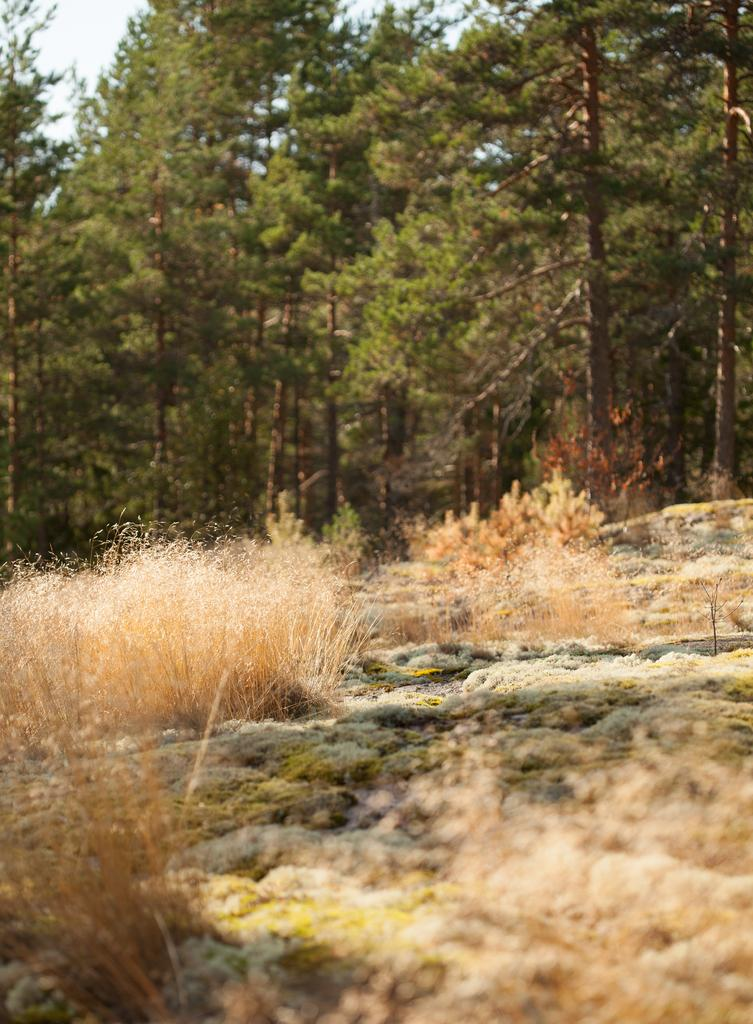What type of plants are in the image? There are dry plants in the image. Where are the dry plants located? The dry plants are on a rock surface. What other vegetation can be seen in the image? There are trees visible in the image. Can you see a giraffe eating cheese from the trees in the image? No, there is no giraffe or cheese present in the image. Is there an amusement park visible in the image? No, there is no amusement park visible in the image. 